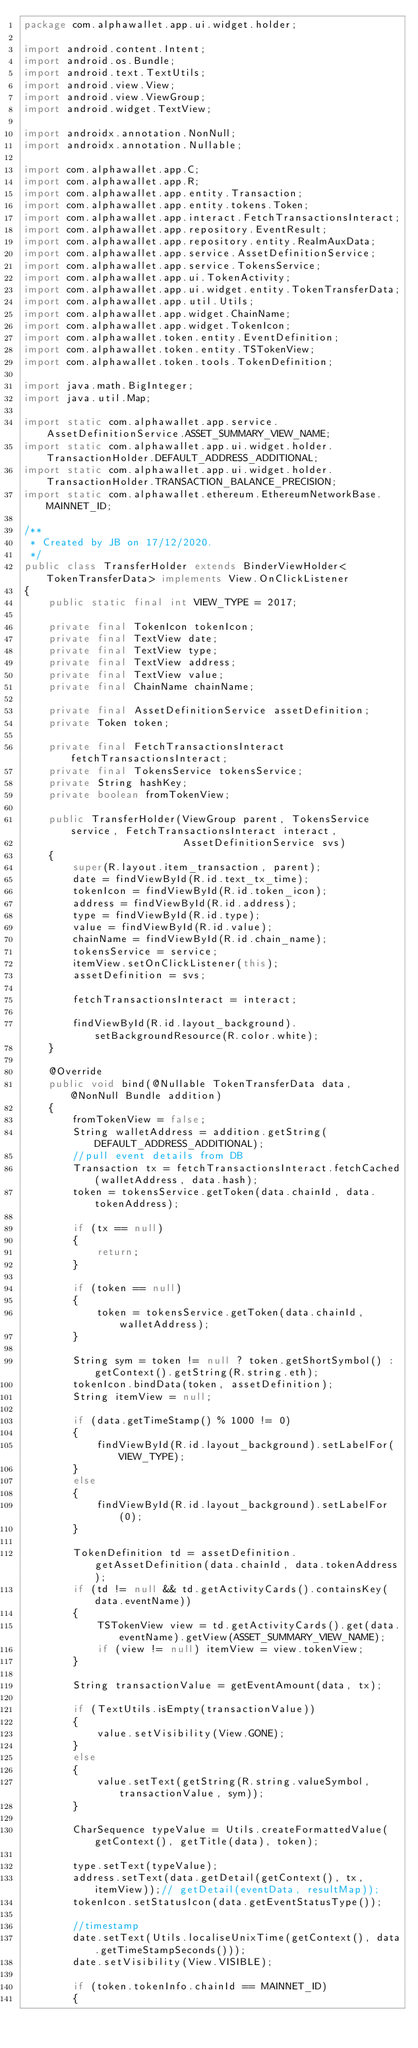<code> <loc_0><loc_0><loc_500><loc_500><_Java_>package com.alphawallet.app.ui.widget.holder;

import android.content.Intent;
import android.os.Bundle;
import android.text.TextUtils;
import android.view.View;
import android.view.ViewGroup;
import android.widget.TextView;

import androidx.annotation.NonNull;
import androidx.annotation.Nullable;

import com.alphawallet.app.C;
import com.alphawallet.app.R;
import com.alphawallet.app.entity.Transaction;
import com.alphawallet.app.entity.tokens.Token;
import com.alphawallet.app.interact.FetchTransactionsInteract;
import com.alphawallet.app.repository.EventResult;
import com.alphawallet.app.repository.entity.RealmAuxData;
import com.alphawallet.app.service.AssetDefinitionService;
import com.alphawallet.app.service.TokensService;
import com.alphawallet.app.ui.TokenActivity;
import com.alphawallet.app.ui.widget.entity.TokenTransferData;
import com.alphawallet.app.util.Utils;
import com.alphawallet.app.widget.ChainName;
import com.alphawallet.app.widget.TokenIcon;
import com.alphawallet.token.entity.EventDefinition;
import com.alphawallet.token.entity.TSTokenView;
import com.alphawallet.token.tools.TokenDefinition;

import java.math.BigInteger;
import java.util.Map;

import static com.alphawallet.app.service.AssetDefinitionService.ASSET_SUMMARY_VIEW_NAME;
import static com.alphawallet.app.ui.widget.holder.TransactionHolder.DEFAULT_ADDRESS_ADDITIONAL;
import static com.alphawallet.app.ui.widget.holder.TransactionHolder.TRANSACTION_BALANCE_PRECISION;
import static com.alphawallet.ethereum.EthereumNetworkBase.MAINNET_ID;

/**
 * Created by JB on 17/12/2020.
 */
public class TransferHolder extends BinderViewHolder<TokenTransferData> implements View.OnClickListener
{
    public static final int VIEW_TYPE = 2017;

    private final TokenIcon tokenIcon;
    private final TextView date;
    private final TextView type;
    private final TextView address;
    private final TextView value;
    private final ChainName chainName;

    private final AssetDefinitionService assetDefinition;
    private Token token;

    private final FetchTransactionsInteract fetchTransactionsInteract;
    private final TokensService tokensService;
    private String hashKey;
    private boolean fromTokenView;

    public TransferHolder(ViewGroup parent, TokensService service, FetchTransactionsInteract interact,
                          AssetDefinitionService svs)
    {
        super(R.layout.item_transaction, parent);
        date = findViewById(R.id.text_tx_time);
        tokenIcon = findViewById(R.id.token_icon);
        address = findViewById(R.id.address);
        type = findViewById(R.id.type);
        value = findViewById(R.id.value);
        chainName = findViewById(R.id.chain_name);
        tokensService = service;
        itemView.setOnClickListener(this);
        assetDefinition = svs;

        fetchTransactionsInteract = interact;

        findViewById(R.id.layout_background).setBackgroundResource(R.color.white);
    }

    @Override
    public void bind(@Nullable TokenTransferData data, @NonNull Bundle addition)
    {
        fromTokenView = false;
        String walletAddress = addition.getString(DEFAULT_ADDRESS_ADDITIONAL);
        //pull event details from DB
        Transaction tx = fetchTransactionsInteract.fetchCached(walletAddress, data.hash);
        token = tokensService.getToken(data.chainId, data.tokenAddress);

        if (tx == null)
        {
            return;
        }

        if (token == null)
        {
            token = tokensService.getToken(data.chainId, walletAddress);
        }

        String sym = token != null ? token.getShortSymbol() : getContext().getString(R.string.eth);
        tokenIcon.bindData(token, assetDefinition);
        String itemView = null;

        if (data.getTimeStamp() % 1000 != 0)
        {
            findViewById(R.id.layout_background).setLabelFor(VIEW_TYPE);
        }
        else
        {
            findViewById(R.id.layout_background).setLabelFor(0);
        }

        TokenDefinition td = assetDefinition.getAssetDefinition(data.chainId, data.tokenAddress);
        if (td != null && td.getActivityCards().containsKey(data.eventName))
        {
            TSTokenView view = td.getActivityCards().get(data.eventName).getView(ASSET_SUMMARY_VIEW_NAME);
            if (view != null) itemView = view.tokenView;
        }

        String transactionValue = getEventAmount(data, tx);

        if (TextUtils.isEmpty(transactionValue))
        {
            value.setVisibility(View.GONE);
        }
        else
        {
            value.setText(getString(R.string.valueSymbol, transactionValue, sym));
        }

        CharSequence typeValue = Utils.createFormattedValue(getContext(), getTitle(data), token);

        type.setText(typeValue);
        address.setText(data.getDetail(getContext(), tx, itemView));// getDetail(eventData, resultMap));
        tokenIcon.setStatusIcon(data.getEventStatusType());

        //timestamp
        date.setText(Utils.localiseUnixTime(getContext(), data.getTimeStampSeconds()));
        date.setVisibility(View.VISIBLE);

        if (token.tokenInfo.chainId == MAINNET_ID)
        {</code> 